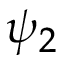<formula> <loc_0><loc_0><loc_500><loc_500>\psi _ { 2 }</formula> 